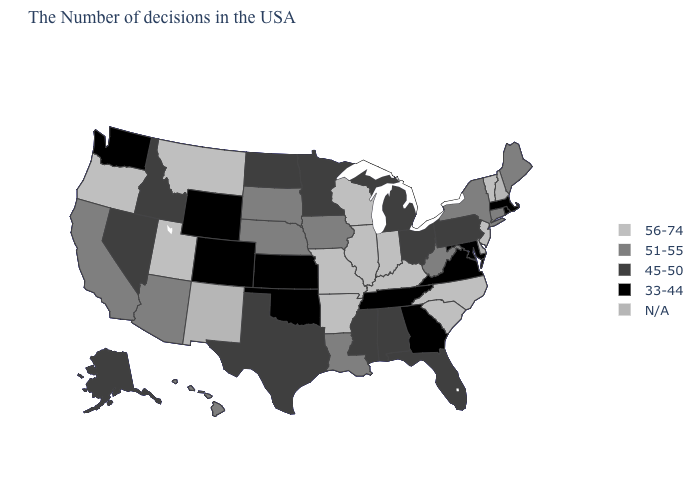Which states hav the highest value in the Northeast?
Be succinct. Vermont, New Jersey. Which states have the highest value in the USA?
Concise answer only. Vermont, New Jersey, North Carolina, South Carolina, Kentucky, Indiana, Wisconsin, Illinois, Missouri, Arkansas, Utah, Montana, Oregon. What is the value of Ohio?
Quick response, please. 45-50. Name the states that have a value in the range 56-74?
Write a very short answer. Vermont, New Jersey, North Carolina, South Carolina, Kentucky, Indiana, Wisconsin, Illinois, Missouri, Arkansas, Utah, Montana, Oregon. Name the states that have a value in the range 56-74?
Answer briefly. Vermont, New Jersey, North Carolina, South Carolina, Kentucky, Indiana, Wisconsin, Illinois, Missouri, Arkansas, Utah, Montana, Oregon. Does Missouri have the lowest value in the USA?
Quick response, please. No. What is the value of Georgia?
Give a very brief answer. 33-44. What is the highest value in the USA?
Concise answer only. 56-74. Name the states that have a value in the range N/A?
Short answer required. New Hampshire, Delaware, New Mexico. What is the highest value in states that border Michigan?
Be succinct. 56-74. What is the value of Oregon?
Quick response, please. 56-74. Among the states that border West Virginia , does Maryland have the lowest value?
Concise answer only. Yes. Name the states that have a value in the range 33-44?
Be succinct. Massachusetts, Rhode Island, Maryland, Virginia, Georgia, Tennessee, Kansas, Oklahoma, Wyoming, Colorado, Washington. Does Massachusetts have the lowest value in the USA?
Give a very brief answer. Yes. Among the states that border Colorado , which have the lowest value?
Give a very brief answer. Kansas, Oklahoma, Wyoming. 